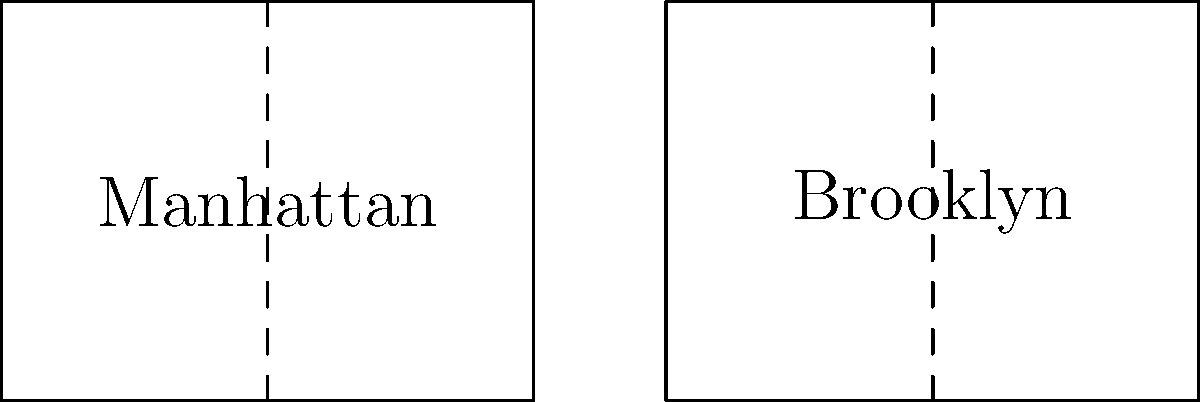In the diagram above, the rectangles represent simplified maps of Manhattan and Brooklyn. If the vertical dashed lines in each borough represent the same distance of 5 miles, which borough covers a larger area? Let's approach this step-by-step:

1. We can see that both rectangles have the same height, representing the north-south distance of each borough.

2. The width of each rectangle represents the east-west distance.

3. In Manhattan:
   - The dashed line divides the rectangle into two equal parts.
   - So the total width is 2 * 5 = 10 miles.

4. In Brooklyn:
   - The dashed line is not in the center, it's slightly to the left.
   - The total width appears to be about 2.5 * 5 = 12.5 miles.

5. Since both rectangles have the same height, we can compare their areas by just comparing their widths.

6. Brooklyn's width (12.5 miles) is greater than Manhattan's (10 miles).

Therefore, the simplified map shows that Brooklyn covers a larger area than Manhattan.
Answer: Brooklyn 